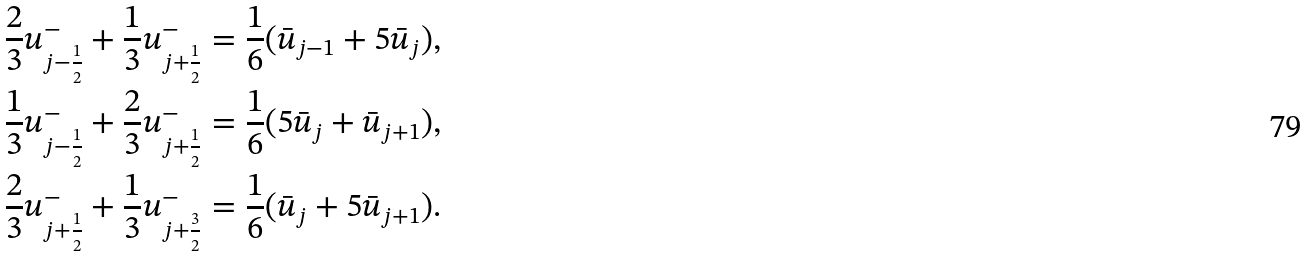Convert formula to latex. <formula><loc_0><loc_0><loc_500><loc_500>\frac { 2 } { 3 } { u } _ { j - \frac { 1 } { 2 } } ^ { - } + \frac { 1 } { 3 } { u } _ { j + \frac { 1 } { 2 } } ^ { - } & = \frac { 1 } { 6 } ( \bar { u } _ { j - 1 } + 5 \bar { u } _ { j } ) , \\ \frac { 1 } { 3 } { u } _ { j - \frac { 1 } { 2 } } ^ { - } + \frac { 2 } { 3 } { u } _ { j + \frac { 1 } { 2 } } ^ { - } & = \frac { 1 } { 6 } ( 5 \bar { u } _ { j } + \bar { u } _ { j + 1 } ) , \\ \frac { 2 } { 3 } { u } _ { j + \frac { 1 } { 2 } } ^ { - } + \frac { 1 } { 3 } { u } _ { j + \frac { 3 } { 2 } } ^ { - } & = \frac { 1 } { 6 } ( \bar { u } _ { j } + 5 \bar { u } _ { j + 1 } ) .</formula> 